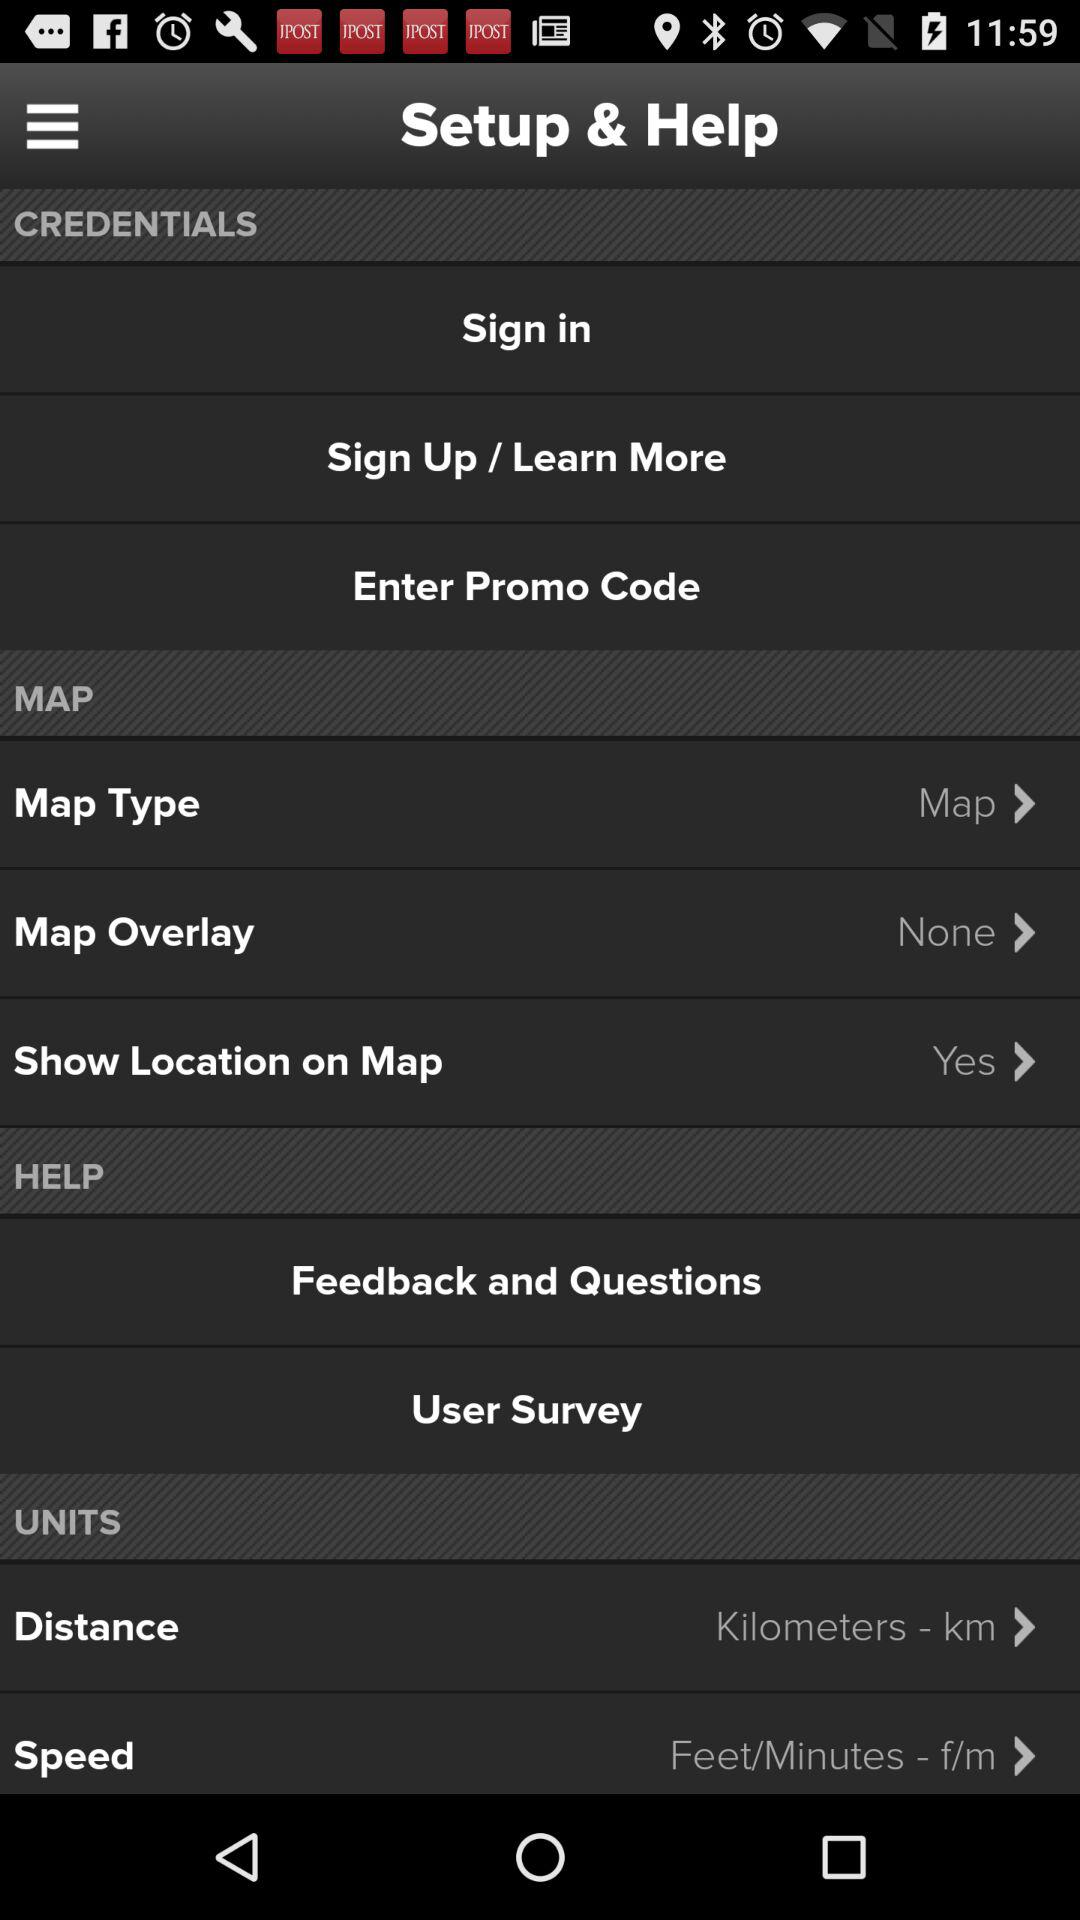What is the selected measuring unit of distance? The measuring unit of distance is kilometers. 